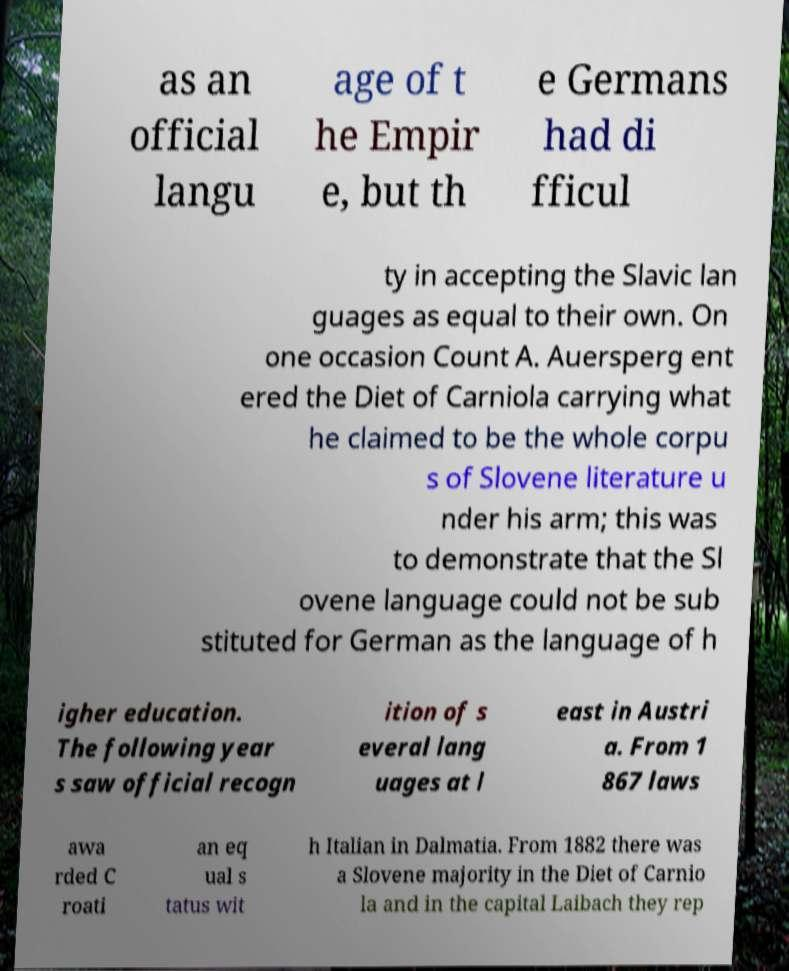Could you assist in decoding the text presented in this image and type it out clearly? as an official langu age of t he Empir e, but th e Germans had di fficul ty in accepting the Slavic lan guages as equal to their own. On one occasion Count A. Auersperg ent ered the Diet of Carniola carrying what he claimed to be the whole corpu s of Slovene literature u nder his arm; this was to demonstrate that the Sl ovene language could not be sub stituted for German as the language of h igher education. The following year s saw official recogn ition of s everal lang uages at l east in Austri a. From 1 867 laws awa rded C roati an eq ual s tatus wit h Italian in Dalmatia. From 1882 there was a Slovene majority in the Diet of Carnio la and in the capital Laibach they rep 